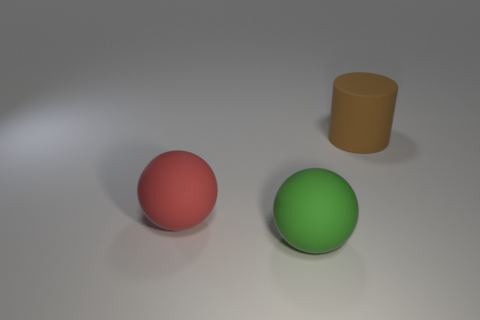How many other objects are there of the same material as the large brown object?
Provide a short and direct response. 2. What number of matte objects are large balls or big cylinders?
Ensure brevity in your answer.  3. Do the big matte object to the left of the green rubber ball and the green thing have the same shape?
Your answer should be very brief. Yes. Are there more big spheres that are on the right side of the large red rubber sphere than large cyan shiny balls?
Give a very brief answer. Yes. How many big rubber spheres are behind the green thing and in front of the red matte ball?
Make the answer very short. 0. There is a large rubber sphere that is to the right of the large rubber sphere left of the green object; what color is it?
Offer a very short reply. Green. Are there fewer red shiny cylinders than big green things?
Your answer should be compact. Yes. Is the number of large brown cylinders to the right of the red object greater than the number of brown objects that are left of the brown cylinder?
Offer a very short reply. Yes. Is the material of the red object the same as the large cylinder?
Offer a terse response. Yes. There is a rubber thing that is on the right side of the big green ball; what number of brown cylinders are left of it?
Offer a very short reply. 0. 